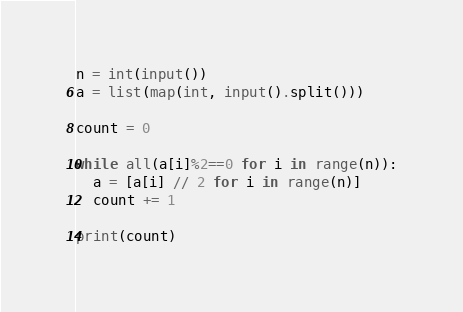Convert code to text. <code><loc_0><loc_0><loc_500><loc_500><_Python_>n = int(input())
a = list(map(int, input().split()))

count = 0

while all(a[i]%2==0 for i in range(n)):
  a = [a[i] // 2 for i in range(n)]
  count += 1
  
print(count)</code> 